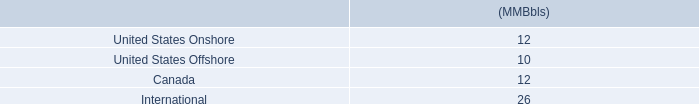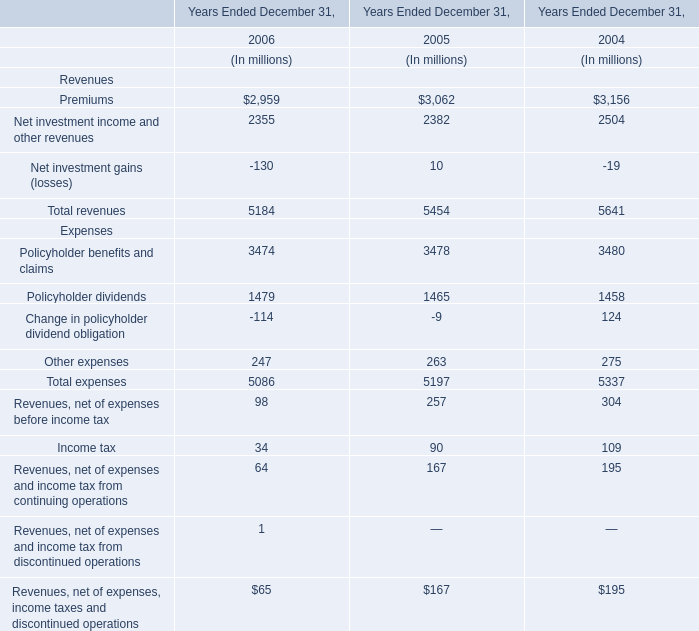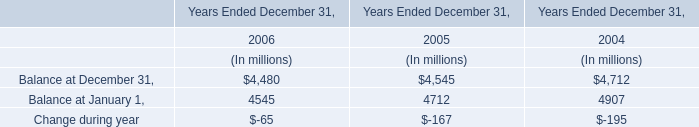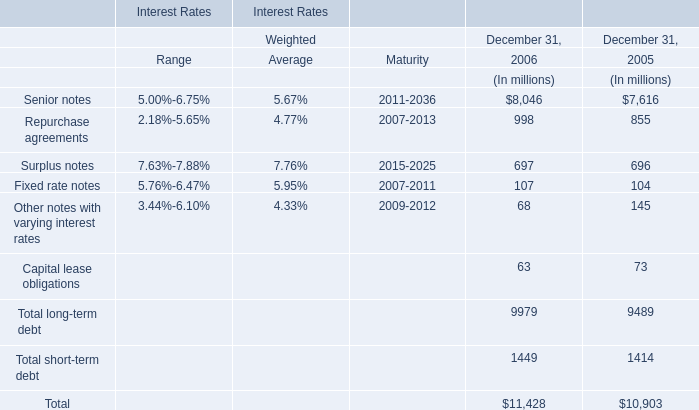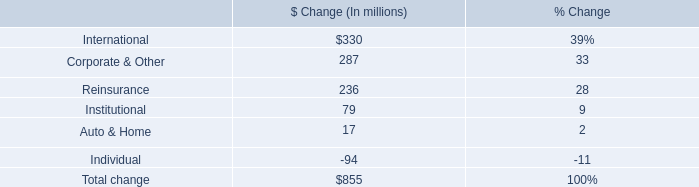What is the sum of the Net investment income and other revenues in the years where Loans reported as trading assets is greater than 3000?? (in million) 
Computations: (2382 + 2504)
Answer: 4886.0. 